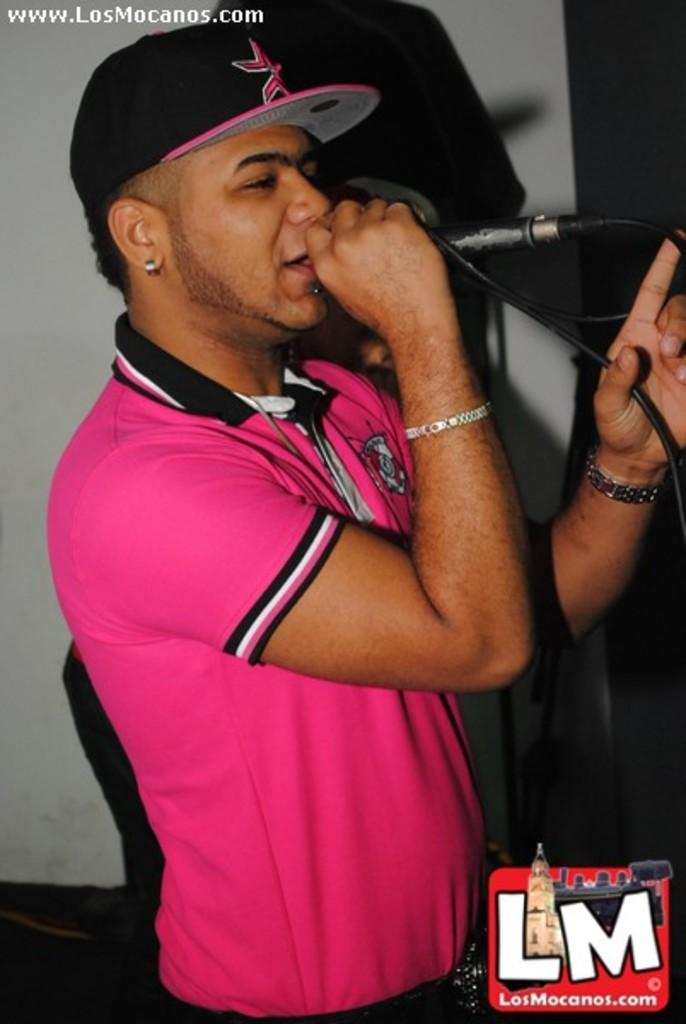Who is the main subject in the image? There is a man in the image. What is the man doing in the image? The man is standing and singing in the image. What is the man using while singing? The man is using a microphone in the image. What type of destruction can be seen happening to the man's home in the image? There is no mention of a home or destruction in the image; it features a man singing with a microphone. 